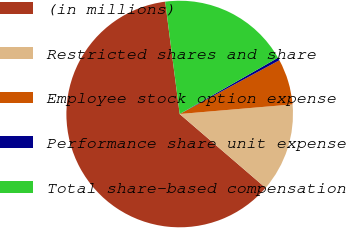Convert chart. <chart><loc_0><loc_0><loc_500><loc_500><pie_chart><fcel>(in millions)<fcel>Restricted shares and share<fcel>Employee stock option expense<fcel>Performance share unit expense<fcel>Total share-based compensation<nl><fcel>61.65%<fcel>12.65%<fcel>6.52%<fcel>0.4%<fcel>18.77%<nl></chart> 